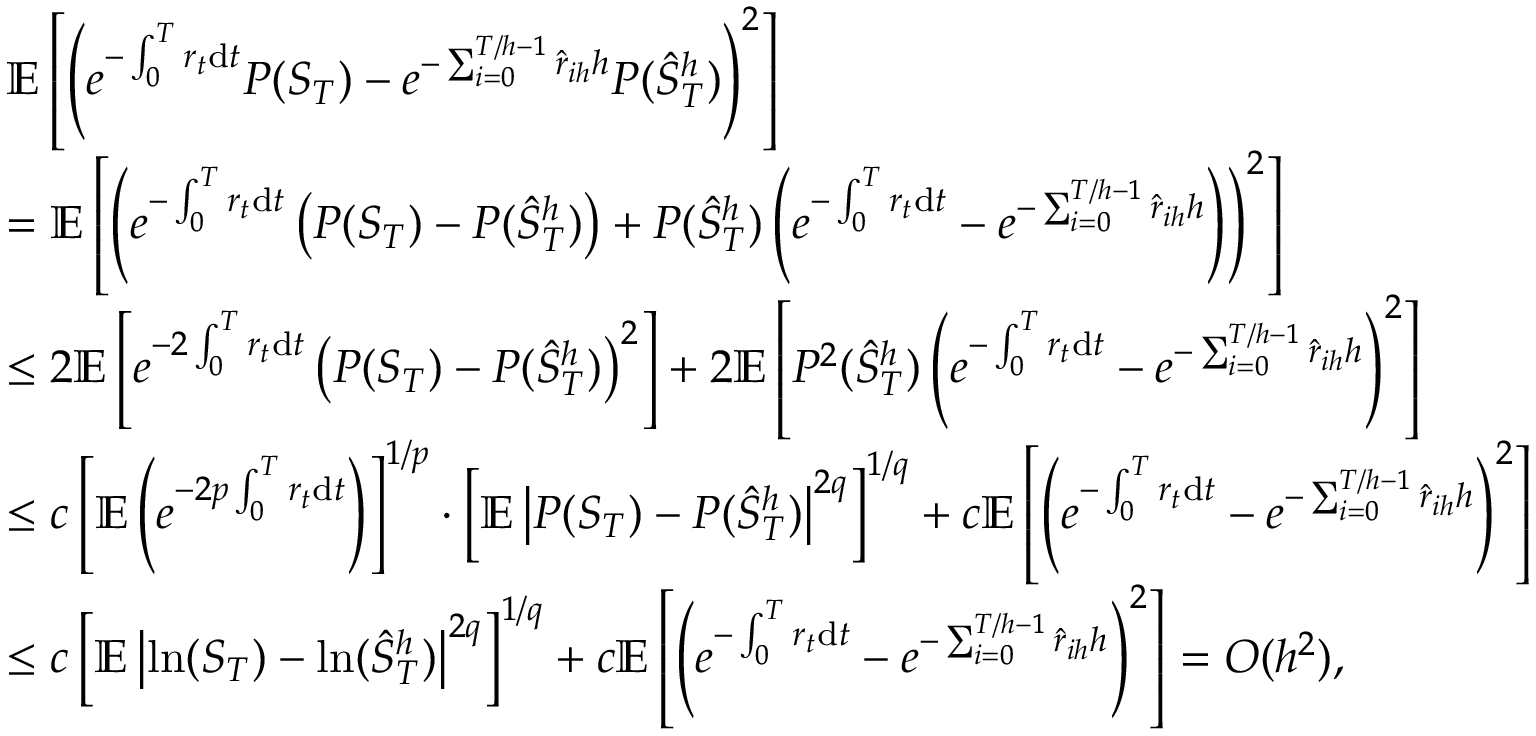<formula> <loc_0><loc_0><loc_500><loc_500>\begin{array} { r l } & { \mathbb { E } \left [ \left ( e ^ { - \int _ { 0 } ^ { T } r _ { t } d t } P ( S _ { T } ) - e ^ { - \sum _ { i = 0 } ^ { T / h - 1 } \hat { r } _ { i h } h } P ( \hat { S } _ { T } ^ { h } ) \right ) ^ { 2 } \right ] } \\ & { = \mathbb { E } \left [ \left ( e ^ { - \int _ { 0 } ^ { T } r _ { t } d t } \left ( P ( S _ { T } ) - P ( \hat { S } _ { T } ^ { h } ) \right ) + P ( \hat { S } _ { T } ^ { h } ) \left ( e ^ { - \int _ { 0 } ^ { T } r _ { t } d t } - e ^ { - \sum _ { i = 0 } ^ { T / h - 1 } \hat { r } _ { i h } h } \right ) \right ) ^ { 2 } \right ] } \\ & { \leq 2 \mathbb { E } \left [ e ^ { - 2 \int _ { 0 } ^ { T } r _ { t } d t } \left ( P ( S _ { T } ) - P ( \hat { S } _ { T } ^ { h } ) \right ) ^ { 2 } \right ] + 2 \mathbb { E } \left [ P ^ { 2 } ( \hat { S } _ { T } ^ { h } ) \left ( e ^ { - \int _ { 0 } ^ { T } r _ { t } d t } - e ^ { - \sum _ { i = 0 } ^ { T / h - 1 } \hat { r } _ { i h } h } \right ) ^ { 2 } \right ] } \\ & { \leq c \left [ \mathbb { E } \left ( e ^ { - 2 p \int _ { 0 } ^ { T } r _ { t } d t } \right ) \right ] ^ { 1 / p } \cdot \left [ \mathbb { E } \left | P ( S _ { T } ) - P ( \hat { S } _ { T } ^ { h } ) \right | ^ { 2 q } \right ] ^ { 1 / q } + c \mathbb { E } \left [ \left ( e ^ { - \int _ { 0 } ^ { T } r _ { t } d t } - e ^ { - \sum _ { i = 0 } ^ { T / h - 1 } \hat { r } _ { i h } h } \right ) ^ { 2 } \right ] } \\ & { \leq c \left [ \mathbb { E } \left | \ln ( S _ { T } ) - \ln ( \hat { S } _ { T } ^ { h } ) \right | ^ { 2 q } \right ] ^ { 1 / q } + c \mathbb { E } \left [ \left ( e ^ { - \int _ { 0 } ^ { T } r _ { t } d t } - e ^ { - \sum _ { i = 0 } ^ { T / h - 1 } \hat { r } _ { i h } h } \right ) ^ { 2 } \right ] = O ( h ^ { 2 } ) , } \end{array}</formula> 